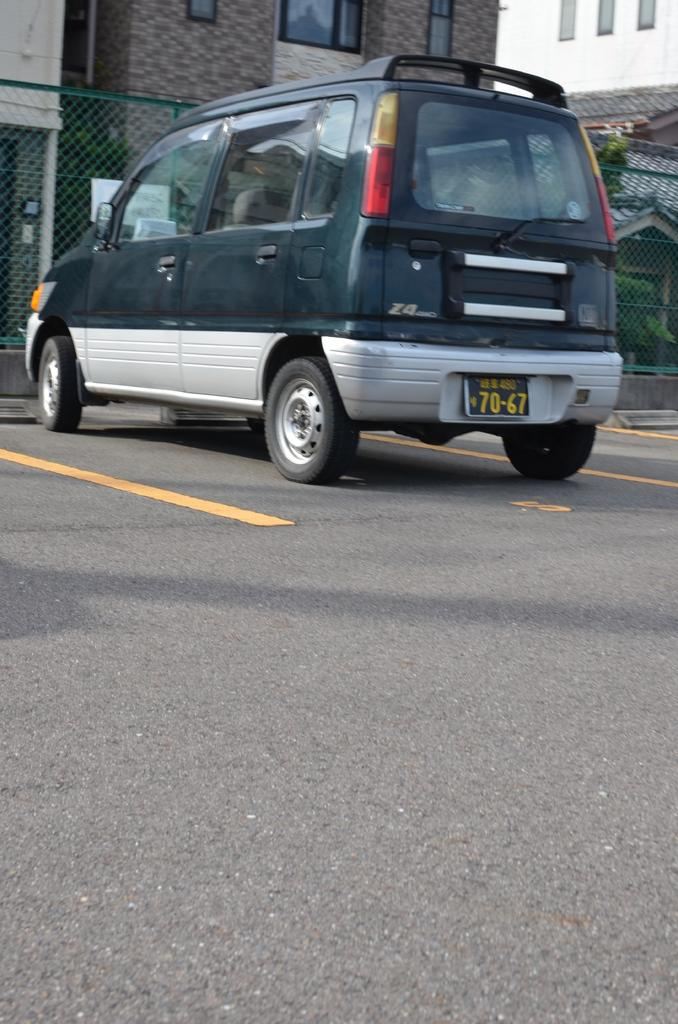What is the main subject of the image? There is a car on the road in the image. What is located behind the car? There is a net fencing behind the car. What can be seen in the distance in the image? There are buildings visible in the background of the image. How does the car attract the attention of passersby in the image? The image does not provide information about the car attracting the attention of passersby, so we cannot answer this question. 